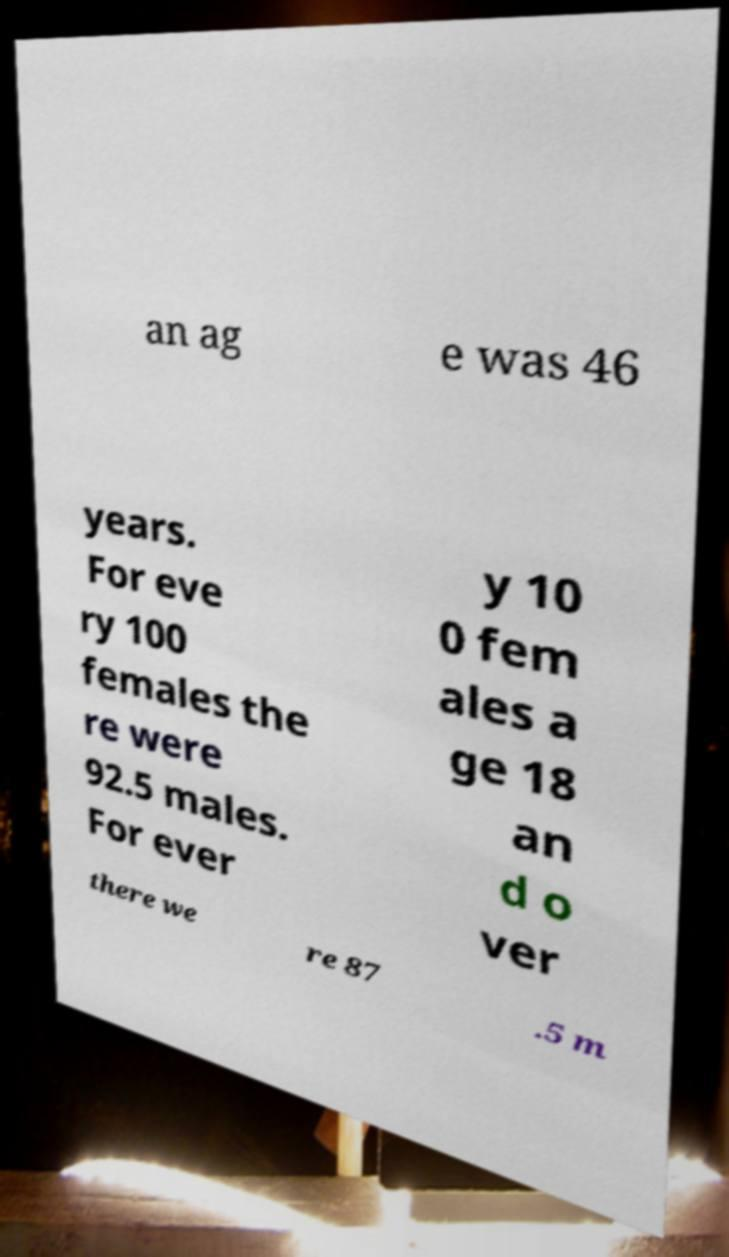Can you read and provide the text displayed in the image?This photo seems to have some interesting text. Can you extract and type it out for me? an ag e was 46 years. For eve ry 100 females the re were 92.5 males. For ever y 10 0 fem ales a ge 18 an d o ver there we re 87 .5 m 